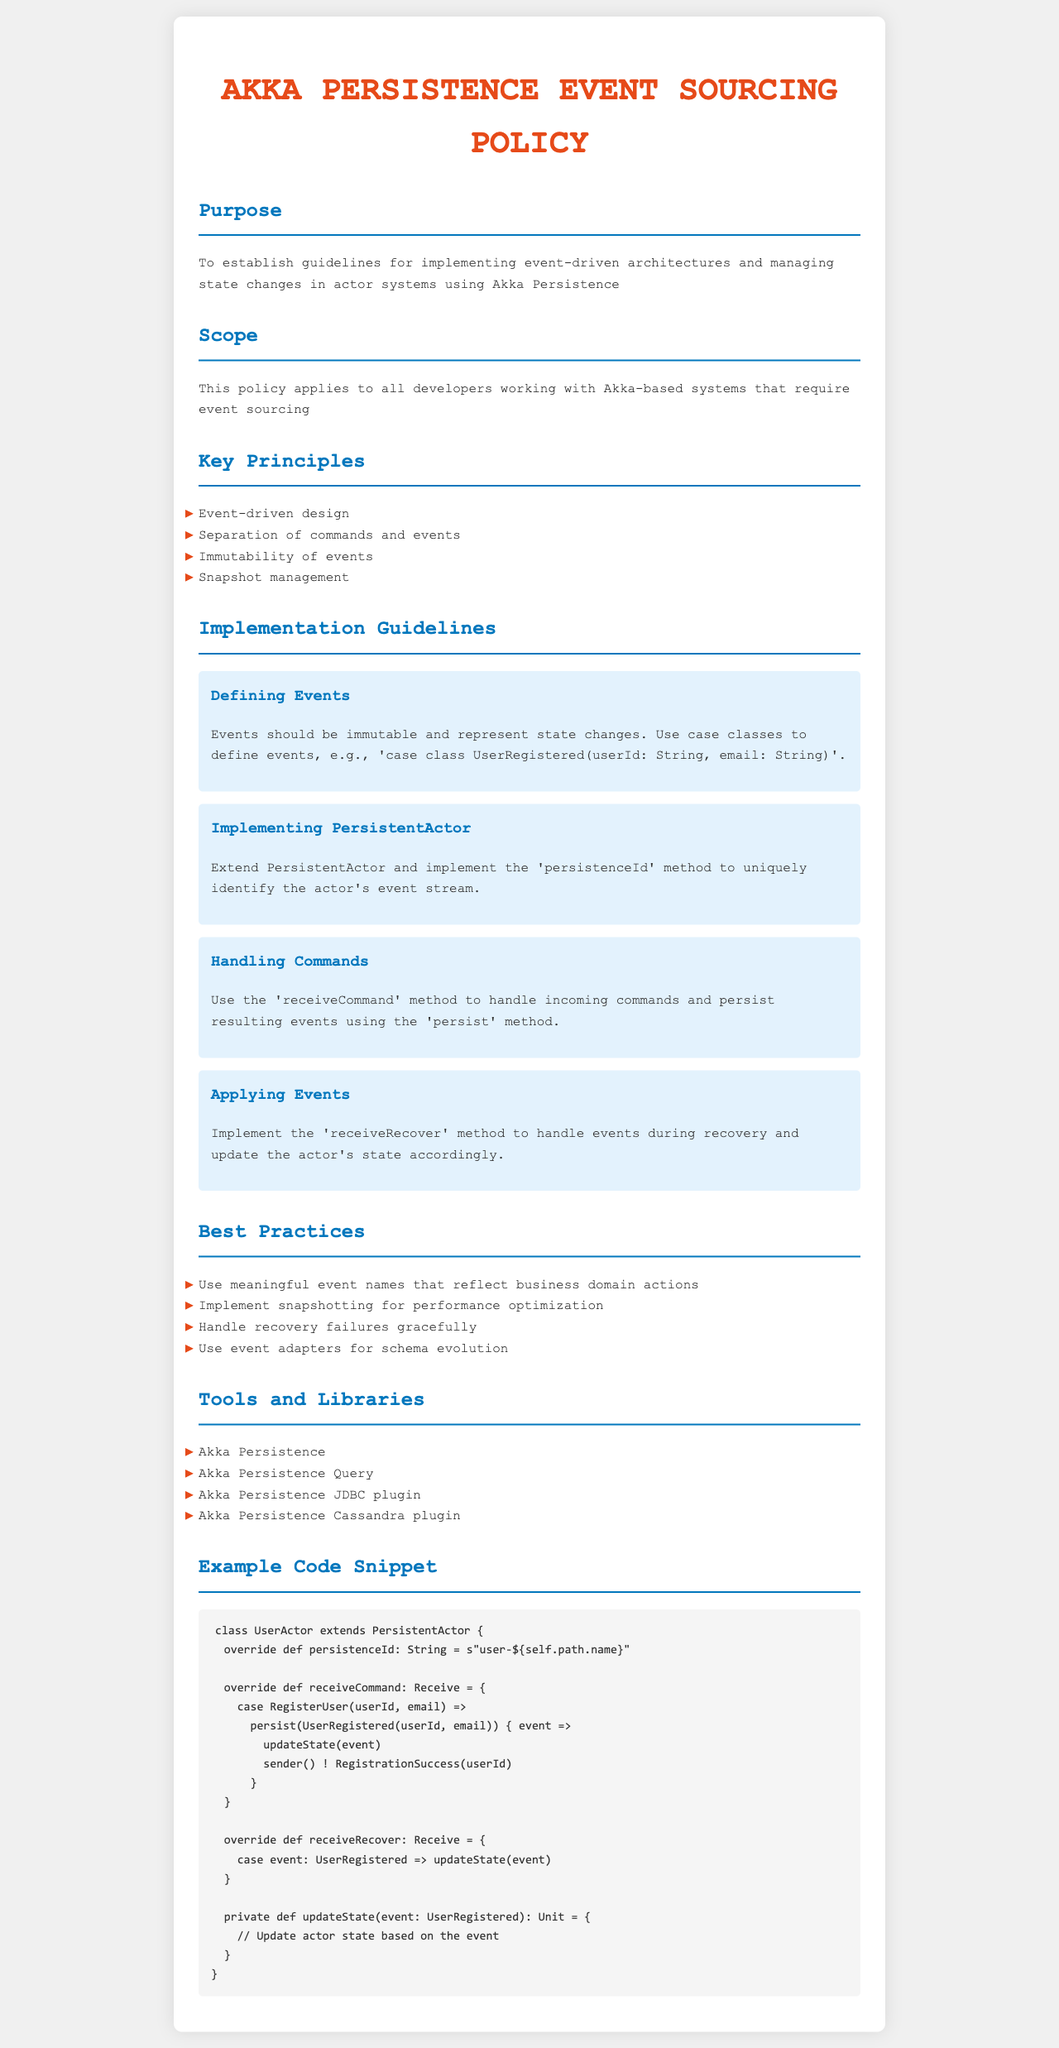What is the purpose of the document? The purpose is to establish guidelines for implementing event-driven architectures and managing state changes in actor systems using Akka Persistence.
Answer: To establish guidelines for implementing event-driven architectures and managing state changes in actor systems using Akka Persistence What does the policy apply to? The policy applies to all developers working with Akka-based systems that require event sourcing.
Answer: All developers working with Akka-based systems that require event sourcing Name one key principle of the policy. Key principles listed in the document include event-driven design, separation of commands and events, immutability of events, and snapshot management.
Answer: Event-driven design How should events be defined according to the guidelines? Guidelines state that events should be immutable and represent state changes, typically defined using case classes.
Answer: Events should be immutable and represent state changes What method is used to handle incoming commands? The document specifies the use of the receiveCommand method to handle incoming commands.
Answer: receiveCommand How should recovery failures be handled? The best practices suggest handling recovery failures gracefully as part of the implementation process.
Answer: Gracefully What is a recommended practice for performance optimization? The document recommends implementing snapshotting for performance optimization.
Answer: Implementing snapshotting Which library is mentioned for use with Akka Persistence? The document mentions various tools and libraries including Akka Persistence Query.
Answer: Akka Persistence Query What should be reflected in event names? The best practices suggest using meaningful event names that reflect business domain actions.
Answer: Reflect business domain actions 